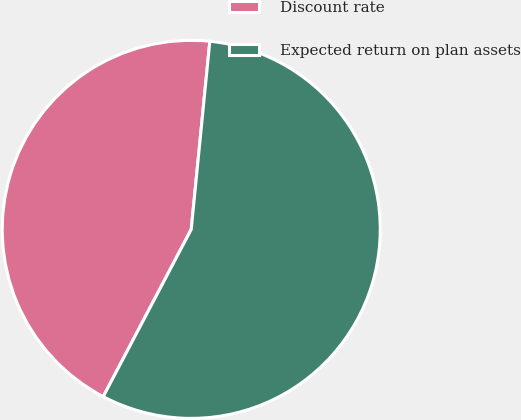<chart> <loc_0><loc_0><loc_500><loc_500><pie_chart><fcel>Discount rate<fcel>Expected return on plan assets<nl><fcel>43.86%<fcel>56.14%<nl></chart> 